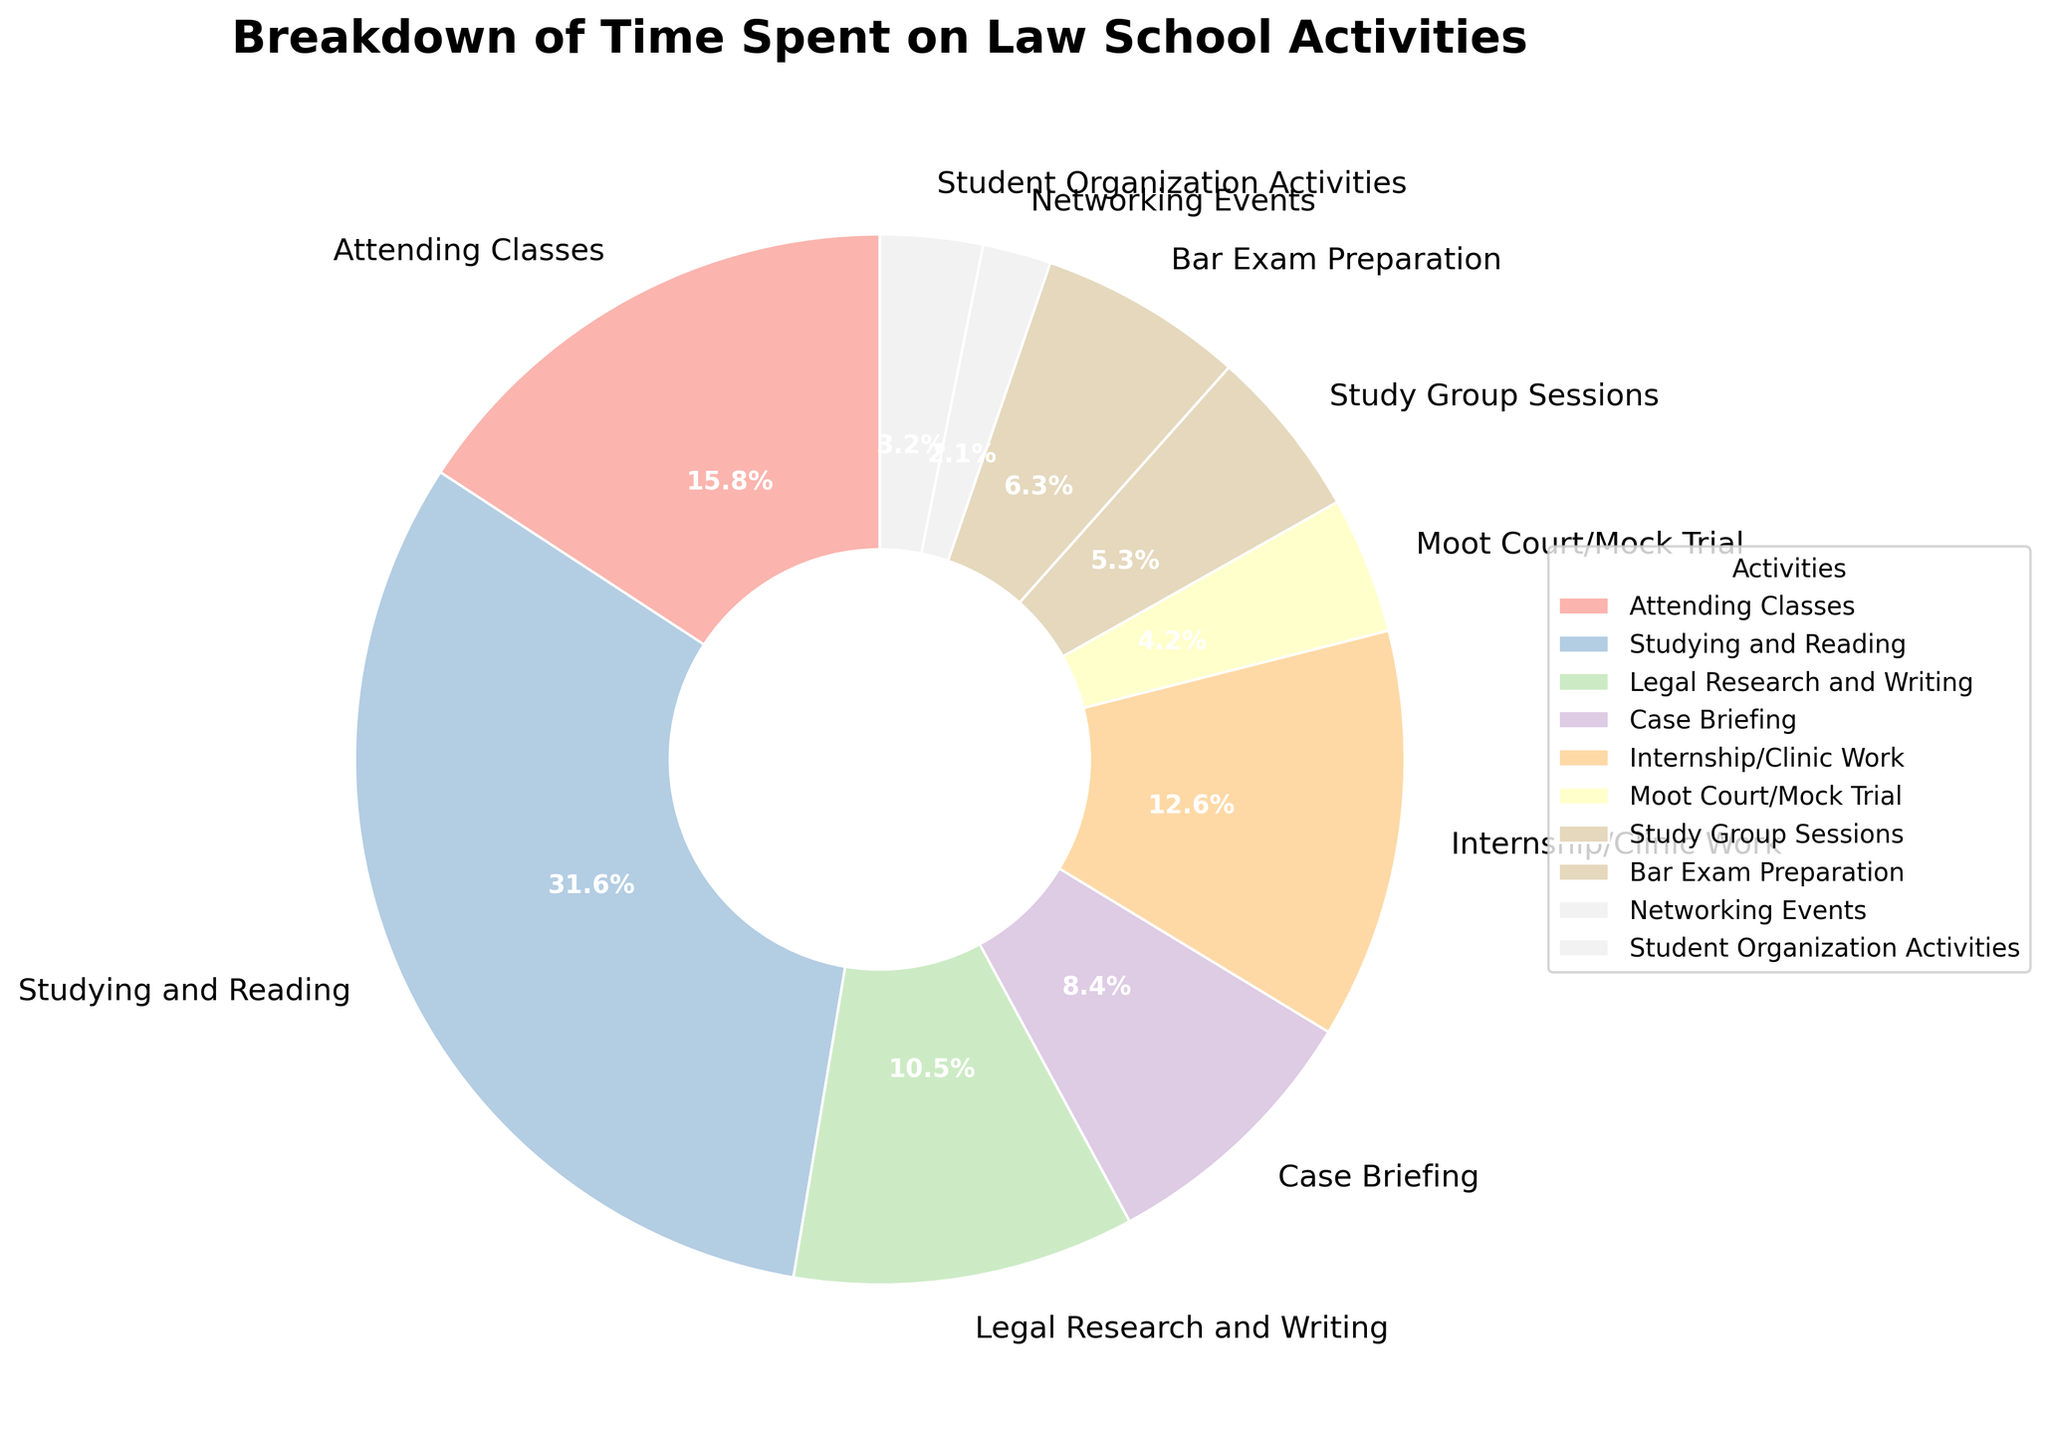What percentage of the time is spent on studying and reading? According to the pie chart, the percentage for each activity is labeled. Locate the label for "Studying and Reading" to find the percentage.
Answer: 30% How much more time is spent on studying and reading compared to internship/clinic work? The hours spent on studying and reading are 30, and for internship/clinic work, it is 12. The difference is calculated by subtracting the smaller value from the larger one: 30 - 12.
Answer: 18 hours Is more time spent on case briefing or on legal research and writing? Review the chart segments for "Case Briefing" and "Legal Research and Writing" to compare them. Case Briefing has 8 hours, and Legal Research and Writing has 10 hours.
Answer: Legal Research and Writing Which activity takes up exactly 5 hours per week? Look at the labels on the chart and find the activity corresponding to 5 hours.
Answer: Study Group Sessions What is the combined percentage of time spent on networking events and student organization activities? From the pie chart, Networking Events account for 2% and Student Organization Activities for 3%. Adding these together, 2% + 3% equals the total percentage.
Answer: 5% Which activity occupies the largest segment of the pie chart, and how much time is dedicated to it? Review each segment size and label on the chart. The largest segment represents the activity, which is "Studying and Reading" with 30 hours.
Answer: Studying and Reading, 30 hours What is the total amount of time spent on attending classes, case briefing, and moot court/mock trial combined? Sum the hours for these activities: Attending Classes (15), Case Briefing (8), and Moot Court/Mock Trial (4). Total is 15 + 8 + 4.
Answer: 27 hours How does the time spent on bar exam preparation compare to that on student organization activities? From the chart, Bar Exam Preparation has 6 hours, and Student Organization Activities has 3 hours. Bar Exam Preparation time is twice that of Student Organization Activities.
Answer: Twice as much If one were to add an hour to each activity, what would the new total weekly hours be? Sum up the original hours for all activities, which total 15 + 30 + 10 + 8 + 12 + 4 + 5 + 6 + 2 + 3 = 95. Adding one hour to each of the 10 activities results in 95 + 10.
Answer: 105 hours 